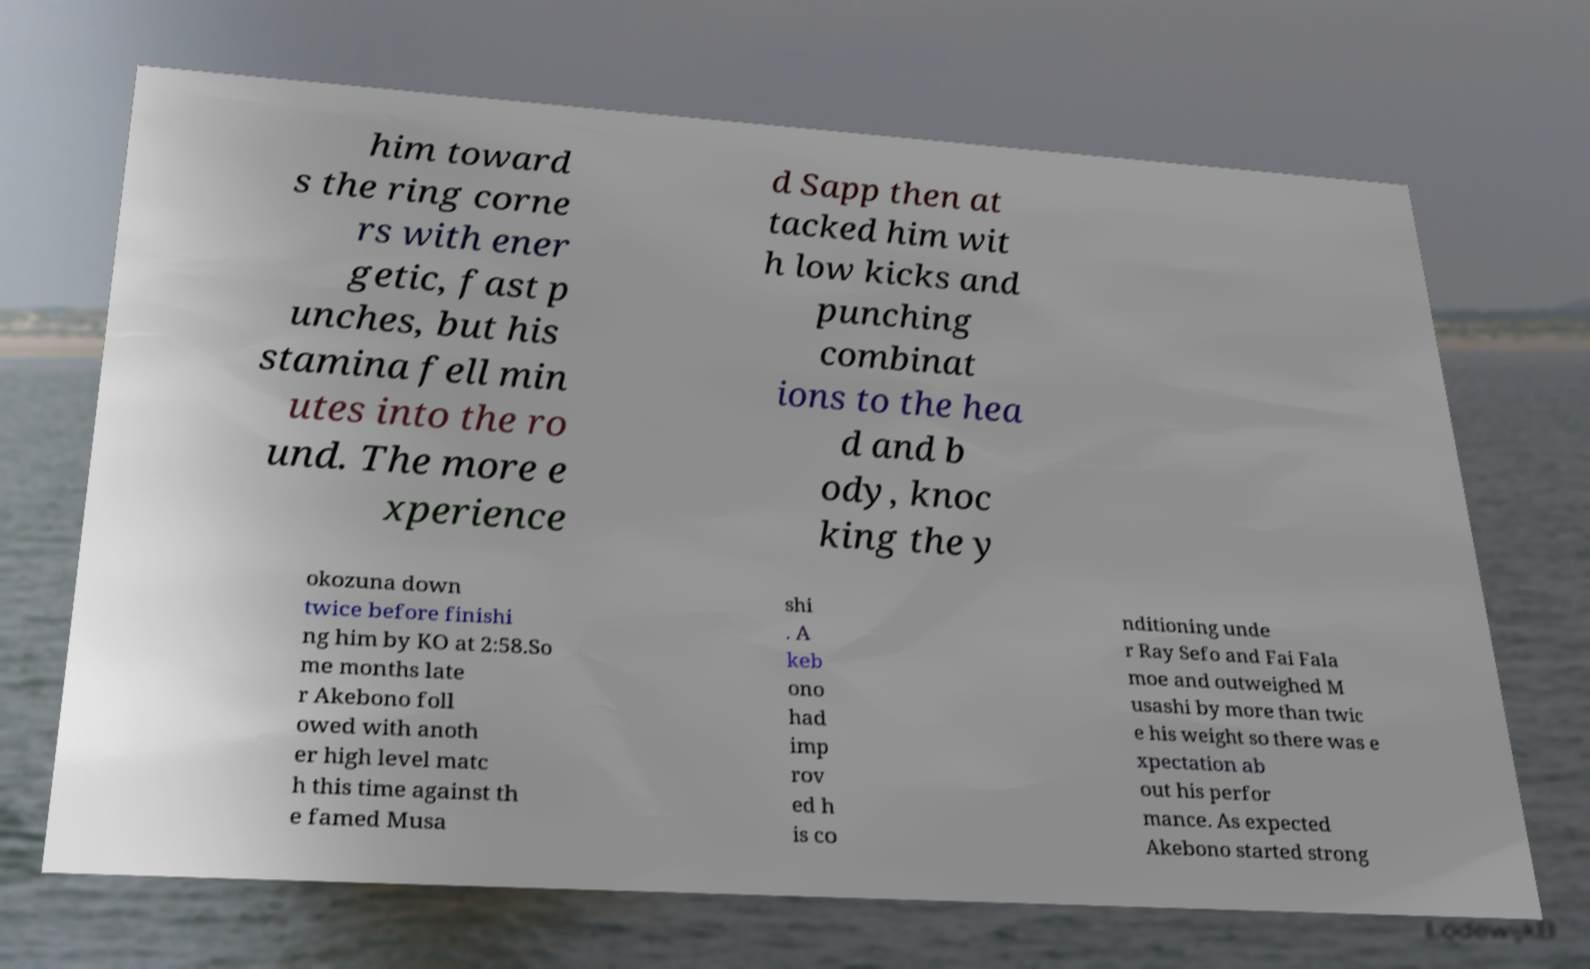There's text embedded in this image that I need extracted. Can you transcribe it verbatim? him toward s the ring corne rs with ener getic, fast p unches, but his stamina fell min utes into the ro und. The more e xperience d Sapp then at tacked him wit h low kicks and punching combinat ions to the hea d and b ody, knoc king the y okozuna down twice before finishi ng him by KO at 2:58.So me months late r Akebono foll owed with anoth er high level matc h this time against th e famed Musa shi . A keb ono had imp rov ed h is co nditioning unde r Ray Sefo and Fai Fala moe and outweighed M usashi by more than twic e his weight so there was e xpectation ab out his perfor mance. As expected Akebono started strong 